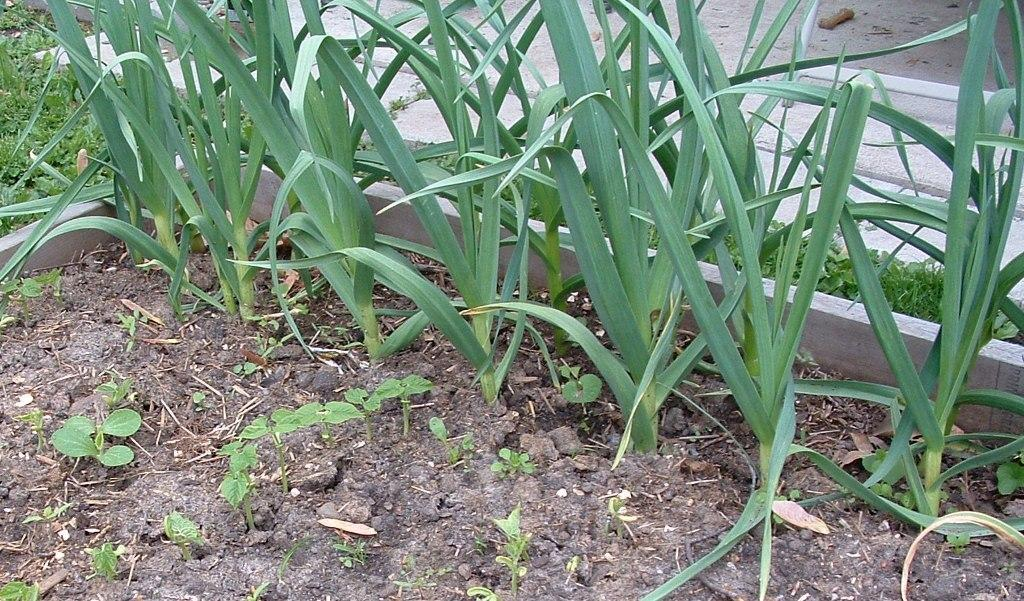What type of plants can be seen in the image? There are green color plants in the image. What type of terrain is visible in the image? There is sand visible in the image. Where is the iron market located in the image? There is no iron market present in the image. What type of order is being followed by the plants in the image? The plants in the image are not following any specific order; they are simply growing in their natural state. 